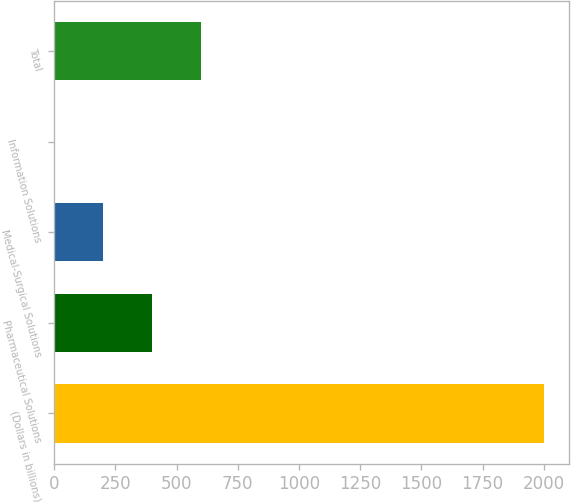Convert chart. <chart><loc_0><loc_0><loc_500><loc_500><bar_chart><fcel>(Dollars in billions)<fcel>Pharmaceutical Solutions<fcel>Medical-Surgical Solutions<fcel>Information Solutions<fcel>Total<nl><fcel>2002<fcel>401.2<fcel>201.1<fcel>1<fcel>601.3<nl></chart> 